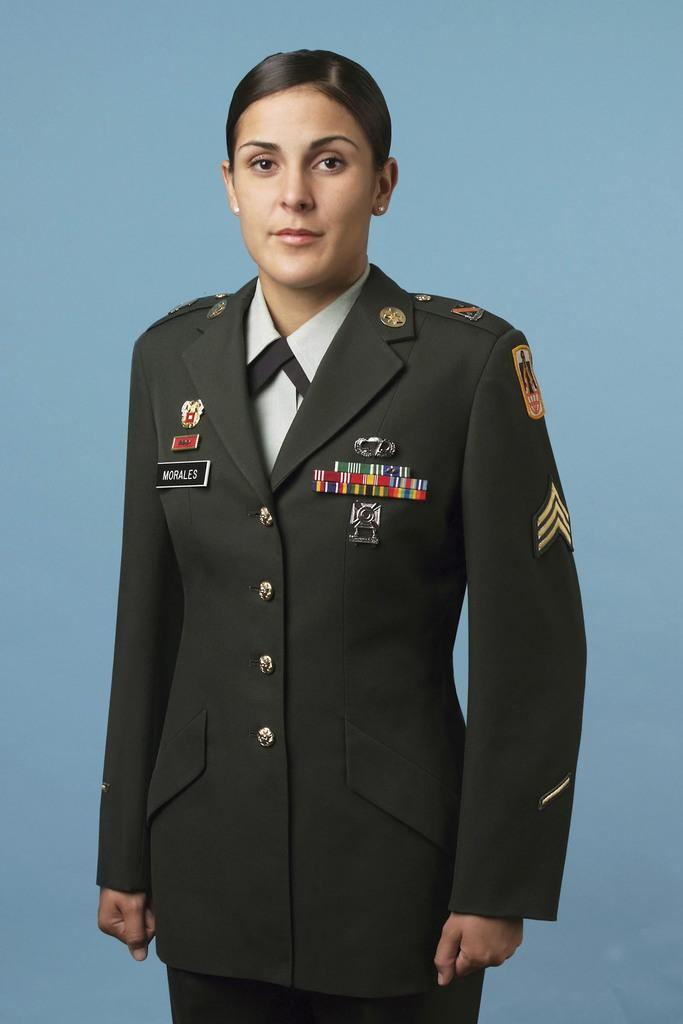What is the main subject of the image? There is an army female officer in the image. Where is the officer positioned in the image? The officer is standing in the center of the image. What type of fish can be seen swimming near the officer in the image? There are no fish present in the image; it features an army female officer standing in the center. What emotion is the officer displaying in the image? The image does not show the officer's emotions, so it cannot be determined from the picture. 